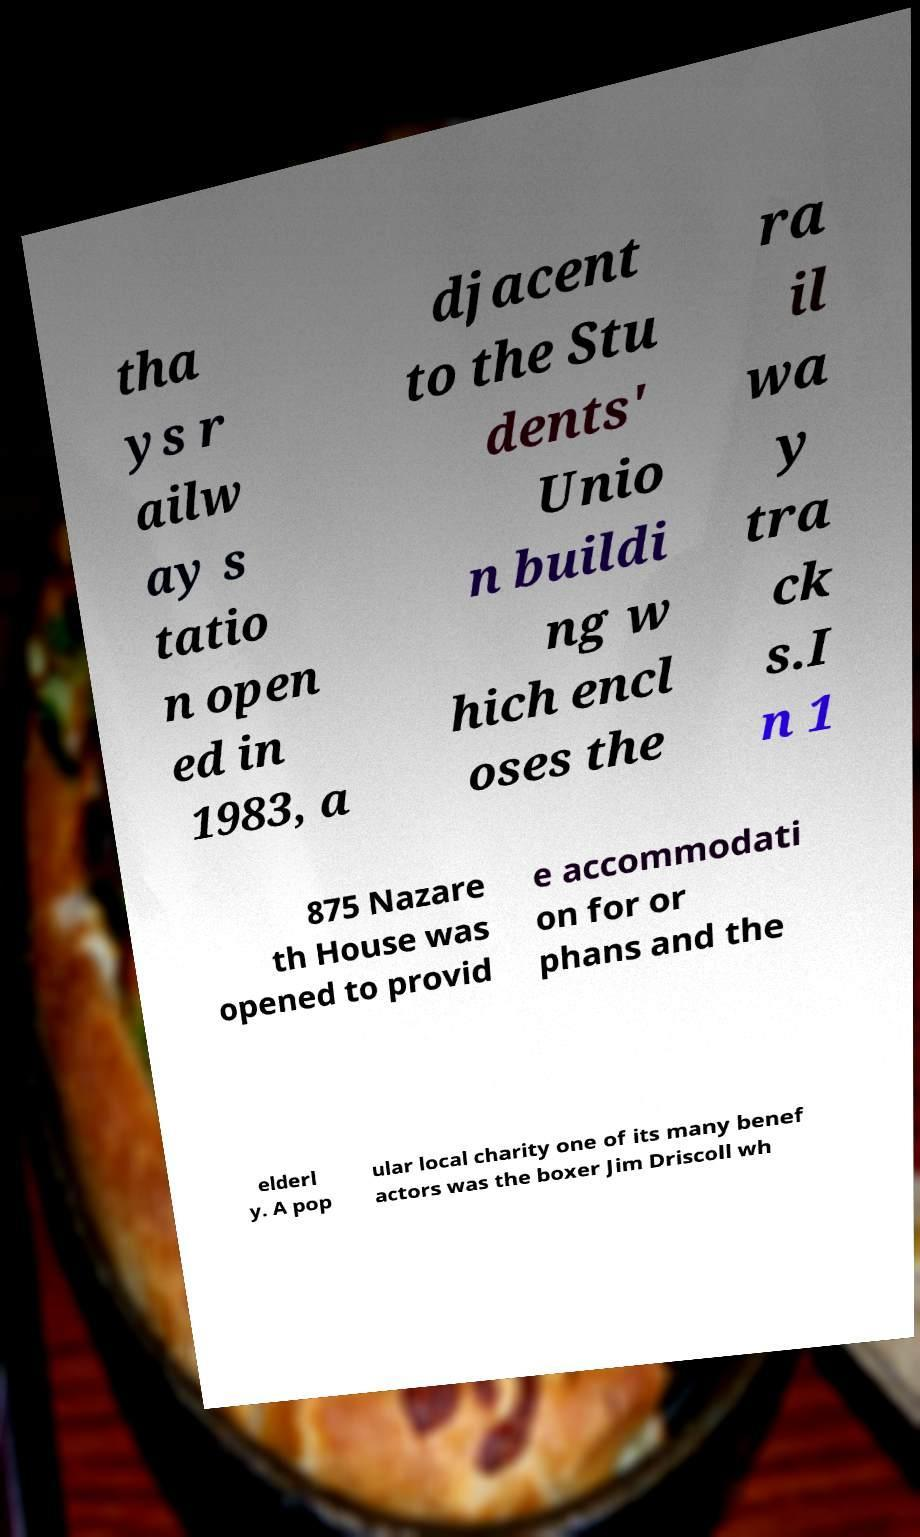Could you assist in decoding the text presented in this image and type it out clearly? tha ys r ailw ay s tatio n open ed in 1983, a djacent to the Stu dents' Unio n buildi ng w hich encl oses the ra il wa y tra ck s.I n 1 875 Nazare th House was opened to provid e accommodati on for or phans and the elderl y. A pop ular local charity one of its many benef actors was the boxer Jim Driscoll wh 